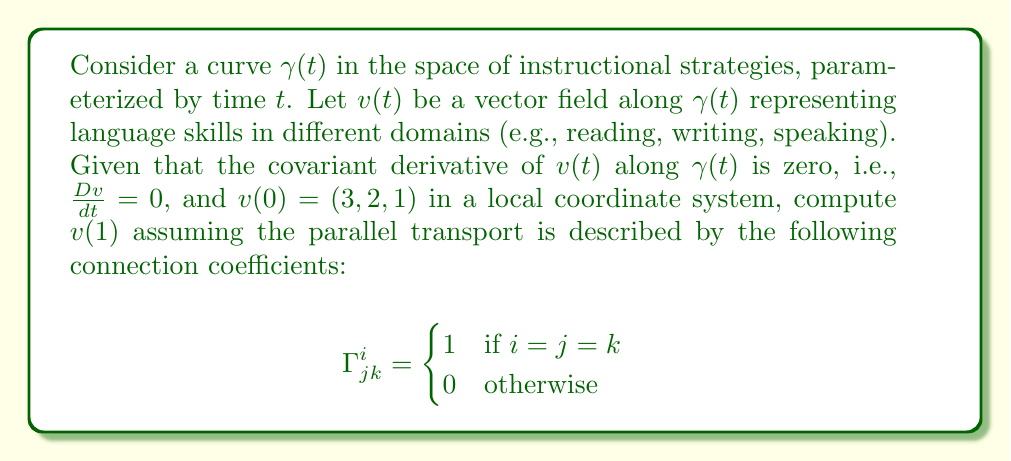Solve this math problem. To solve this problem, we'll follow these steps:

1) The equation for parallel transport along a curve $\gamma(t)$ is given by:

   $$\frac{dv^i}{dt} + \Gamma^i_{jk} \frac{d\gamma^j}{dt} v^k = 0$$

2) Given the connection coefficients, this equation simplifies to:

   $$\frac{dv^i}{dt} + \frac{d\gamma^i}{dt} v^i = 0$$ (no sum over $i$)

3) This can be rewritten as:

   $$\frac{d}{dt}(\ln v^i) = -\frac{d\gamma^i}{dt}$$

4) Integrating both sides from 0 to 1:

   $$\ln v^i(1) - \ln v^i(0) = -(\gamma^i(1) - \gamma^i(0))$$

5) Exponentiating both sides:

   $$v^i(1) = v^i(0) e^{-(\gamma^i(1) - \gamma^i(0))}$$

6) We're given $v(0) = (3, 2, 1)$, so:

   $$v^1(1) = 3e^{-(\gamma^1(1) - \gamma^1(0))}$$
   $$v^2(1) = 2e^{-(\gamma^2(1) - \gamma^2(0))}$$
   $$v^3(1) = 1e^{-(\gamma^3(1) - \gamma^3(0))}$$

7) Without specific information about $\gamma(t)$, we can't simplify further. The final answer depends on the change in $\gamma(t)$ from $t=0$ to $t=1$.
Answer: $v(1) = (3e^{-(\gamma^1(1) - \gamma^1(0))}, 2e^{-(\gamma^2(1) - \gamma^2(0))}, e^{-(\gamma^3(1) - \gamma^3(0))})$ 